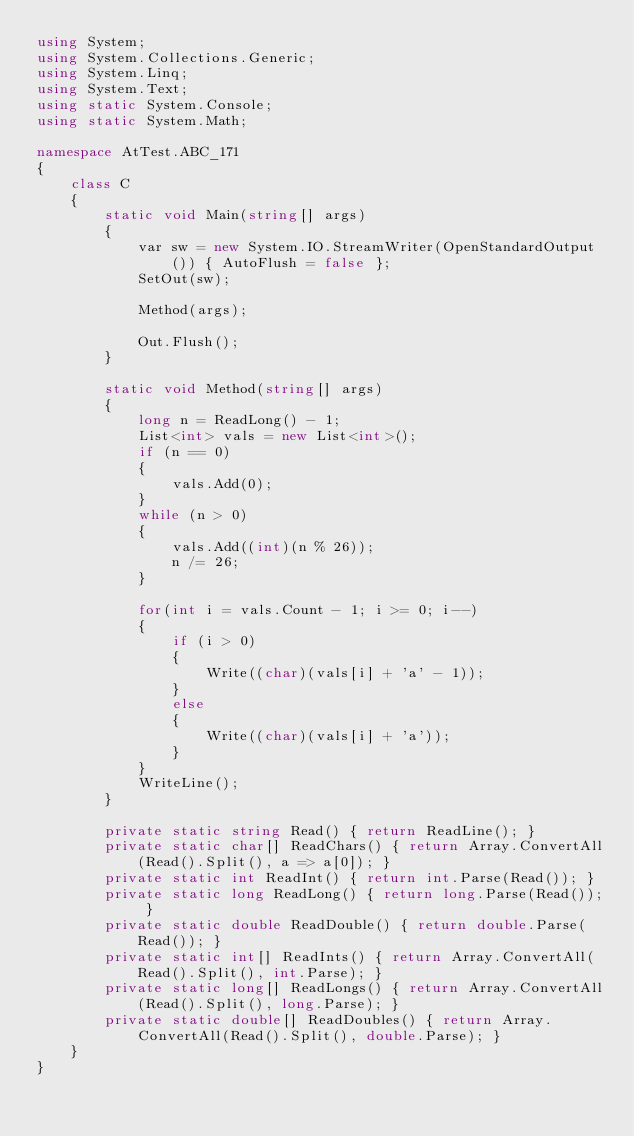<code> <loc_0><loc_0><loc_500><loc_500><_C#_>using System;
using System.Collections.Generic;
using System.Linq;
using System.Text;
using static System.Console;
using static System.Math;

namespace AtTest.ABC_171
{
    class C
    {
        static void Main(string[] args)
        {
            var sw = new System.IO.StreamWriter(OpenStandardOutput()) { AutoFlush = false };
            SetOut(sw);

            Method(args);

            Out.Flush();
        }

        static void Method(string[] args)
        {
            long n = ReadLong() - 1;
            List<int> vals = new List<int>();
            if (n == 0)
            {
                vals.Add(0);
            }
            while (n > 0)
            {
                vals.Add((int)(n % 26));
                n /= 26;
            }

            for(int i = vals.Count - 1; i >= 0; i--)
            {
                if (i > 0)
                {
                    Write((char)(vals[i] + 'a' - 1));
                }
                else
                {
                    Write((char)(vals[i] + 'a'));
                }
            }
            WriteLine();
        }

        private static string Read() { return ReadLine(); }
        private static char[] ReadChars() { return Array.ConvertAll(Read().Split(), a => a[0]); }
        private static int ReadInt() { return int.Parse(Read()); }
        private static long ReadLong() { return long.Parse(Read()); }
        private static double ReadDouble() { return double.Parse(Read()); }
        private static int[] ReadInts() { return Array.ConvertAll(Read().Split(), int.Parse); }
        private static long[] ReadLongs() { return Array.ConvertAll(Read().Split(), long.Parse); }
        private static double[] ReadDoubles() { return Array.ConvertAll(Read().Split(), double.Parse); }
    }
}
</code> 